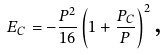Convert formula to latex. <formula><loc_0><loc_0><loc_500><loc_500>E _ { C } = - \frac { P ^ { 2 } } { 1 6 } \left ( 1 + \frac { P _ { C } } { P } \right ) ^ { 2 } \text {,}</formula> 